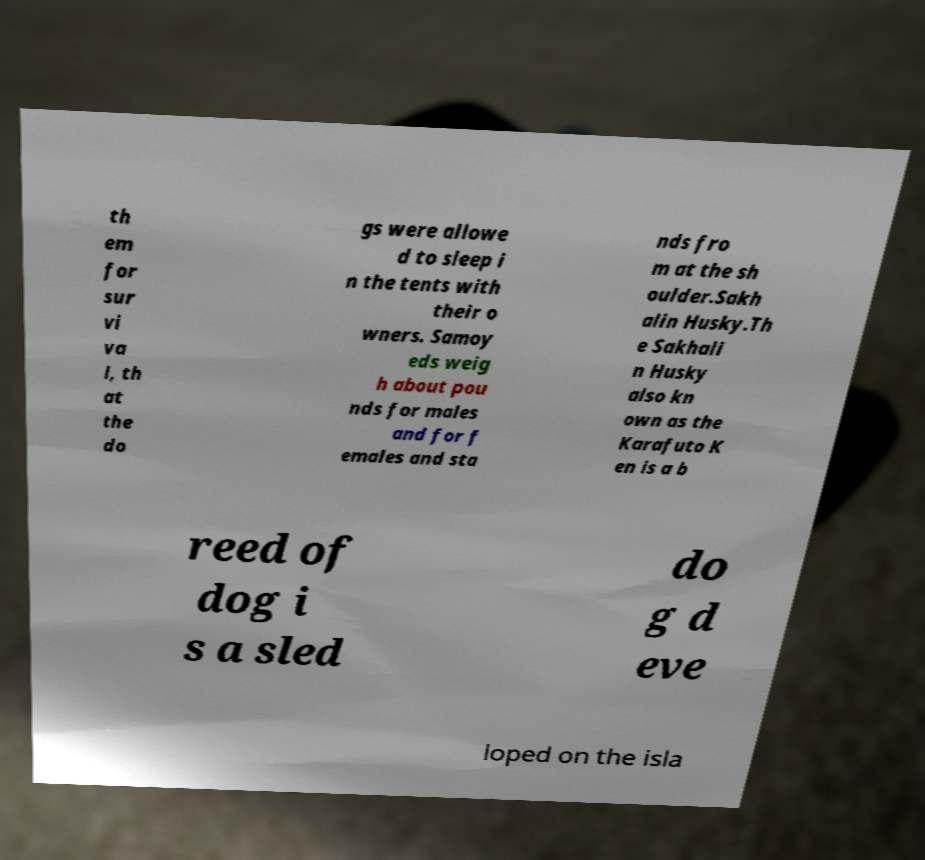For documentation purposes, I need the text within this image transcribed. Could you provide that? th em for sur vi va l, th at the do gs were allowe d to sleep i n the tents with their o wners. Samoy eds weig h about pou nds for males and for f emales and sta nds fro m at the sh oulder.Sakh alin Husky.Th e Sakhali n Husky also kn own as the Karafuto K en is a b reed of dog i s a sled do g d eve loped on the isla 